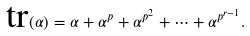Convert formula to latex. <formula><loc_0><loc_0><loc_500><loc_500>\text {tr} ( \alpha ) = \alpha + \alpha ^ { p } + \alpha ^ { p ^ { 2 } } + \cdots + \alpha ^ { p ^ { r - 1 } } .</formula> 